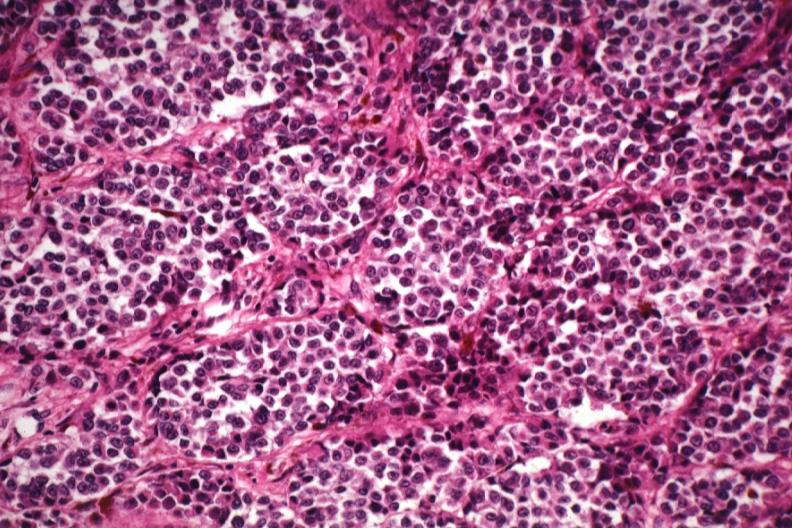does metastatic adenocarcinoma show good tumor cells with little pigment except in melanophores?
Answer the question using a single word or phrase. No 